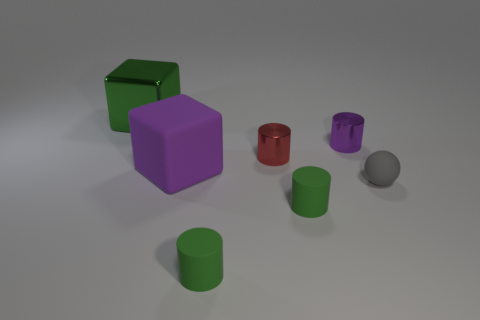What material is the cylinder that is both right of the red shiny thing and in front of the ball?
Your response must be concise. Rubber. What number of purple objects are either big shiny objects or blocks?
Give a very brief answer. 1. How many other things are there of the same size as the purple matte object?
Ensure brevity in your answer.  1. How many green rubber cylinders are there?
Ensure brevity in your answer.  2. Is there any other thing that is the same shape as the gray rubber object?
Your answer should be compact. No. Is the material of the green thing that is behind the small ball the same as the big object in front of the large green object?
Make the answer very short. No. What is the tiny red cylinder made of?
Provide a short and direct response. Metal. How many small gray objects are the same material as the red cylinder?
Provide a short and direct response. 0. How many metallic objects are either big green things or big yellow objects?
Offer a terse response. 1. Does the matte thing behind the matte sphere have the same shape as the green thing that is behind the matte sphere?
Offer a very short reply. Yes. 